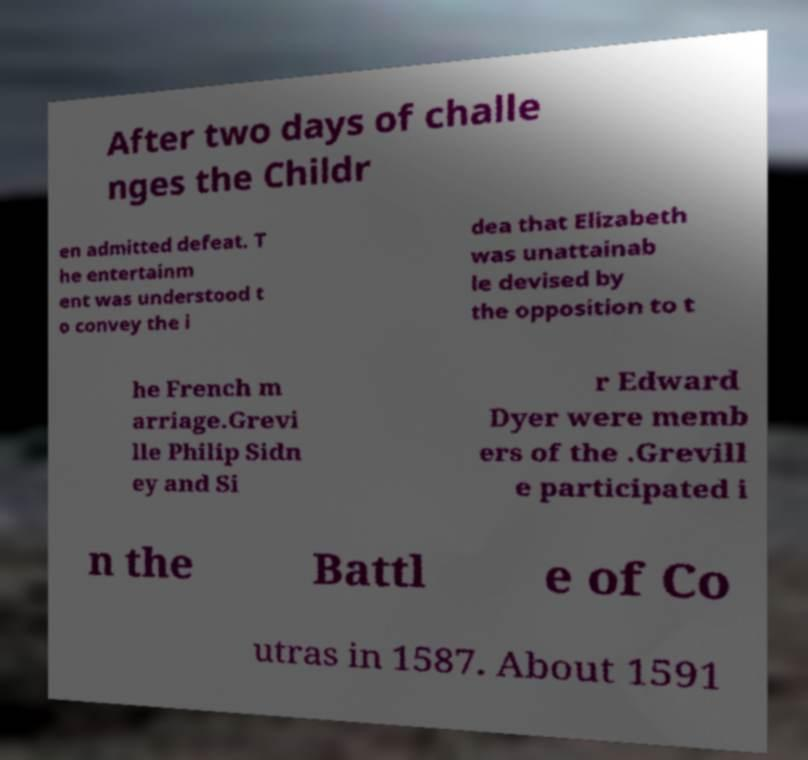For documentation purposes, I need the text within this image transcribed. Could you provide that? After two days of challe nges the Childr en admitted defeat. T he entertainm ent was understood t o convey the i dea that Elizabeth was unattainab le devised by the opposition to t he French m arriage.Grevi lle Philip Sidn ey and Si r Edward Dyer were memb ers of the .Grevill e participated i n the Battl e of Co utras in 1587. About 1591 